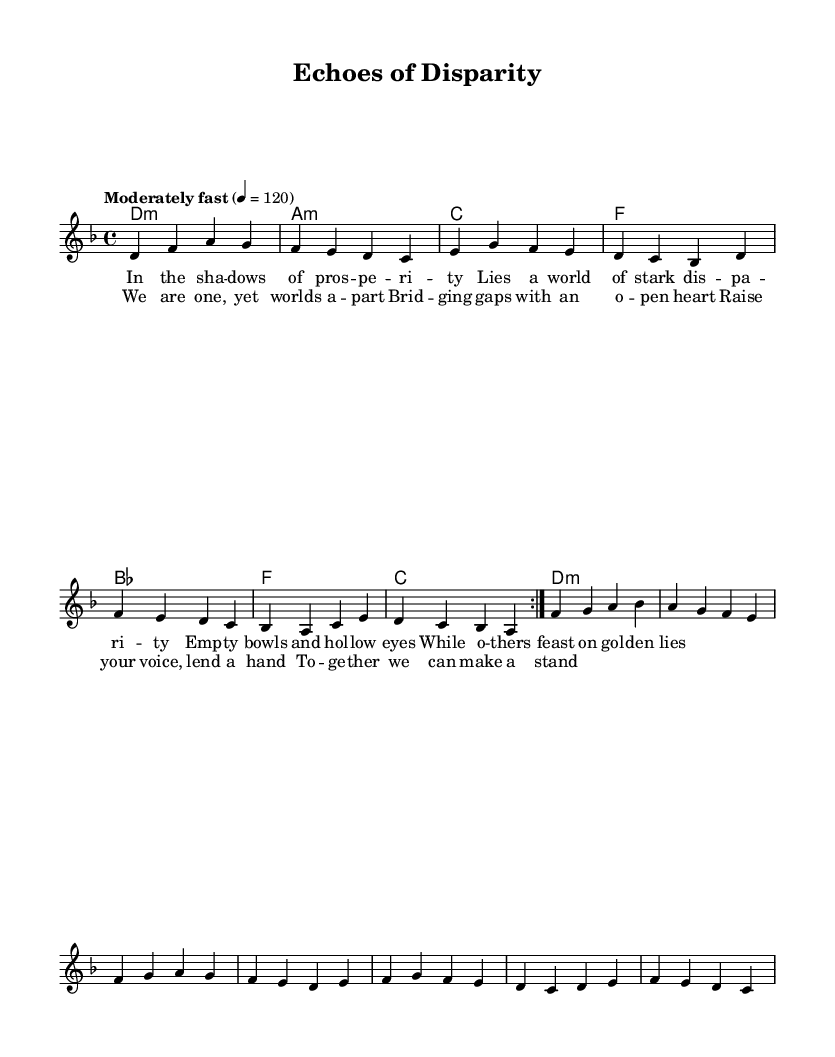What is the key signature of this music? The key signature is marked in the global section with a `\key d \minor` declaration, indicating that the piece is composed in D minor, which has one flat (B flat).
Answer: D minor What is the time signature of this music? The time signature is indicated with `\time 4/4` in the global section, which defines the rhythmic structure of the piece as having four beats in a measure.
Answer: 4/4 What is the tempo marking for this music? The tempo is specified in the global section as `\tempo "Moderately fast" 4 = 120`, meaning the music should be played at a moderate speed of 120 beats per minute (bpm).
Answer: 120 What is the tonic chord of the piece? The tonic chord is presented first in the harmonies section with `d1:m`, indicating that the piece begins on the D minor chord, which is the home chord of the minor key context.
Answer: D minor How many measures are in the verse section? The verse is described as having four lines of lyrics, with each line corresponding to one measure, giving a total of four measures for the verse section.
Answer: 4 What themes are reflected in the lyrics of this song? The lyrics contain themes related to disparity and inequality, addressing humanitarian crises such as empty bowls and hollow eyes, portraying a stark contrast between wealth and poverty.
Answer: Disparity and inequality What is the main message in the chorus of the song? The chorus conveys a message of unity and collective action, emphasizing the idea of bridging gaps and raising one's voice to combat inequality and make a stand together.
Answer: Unity and collective action 